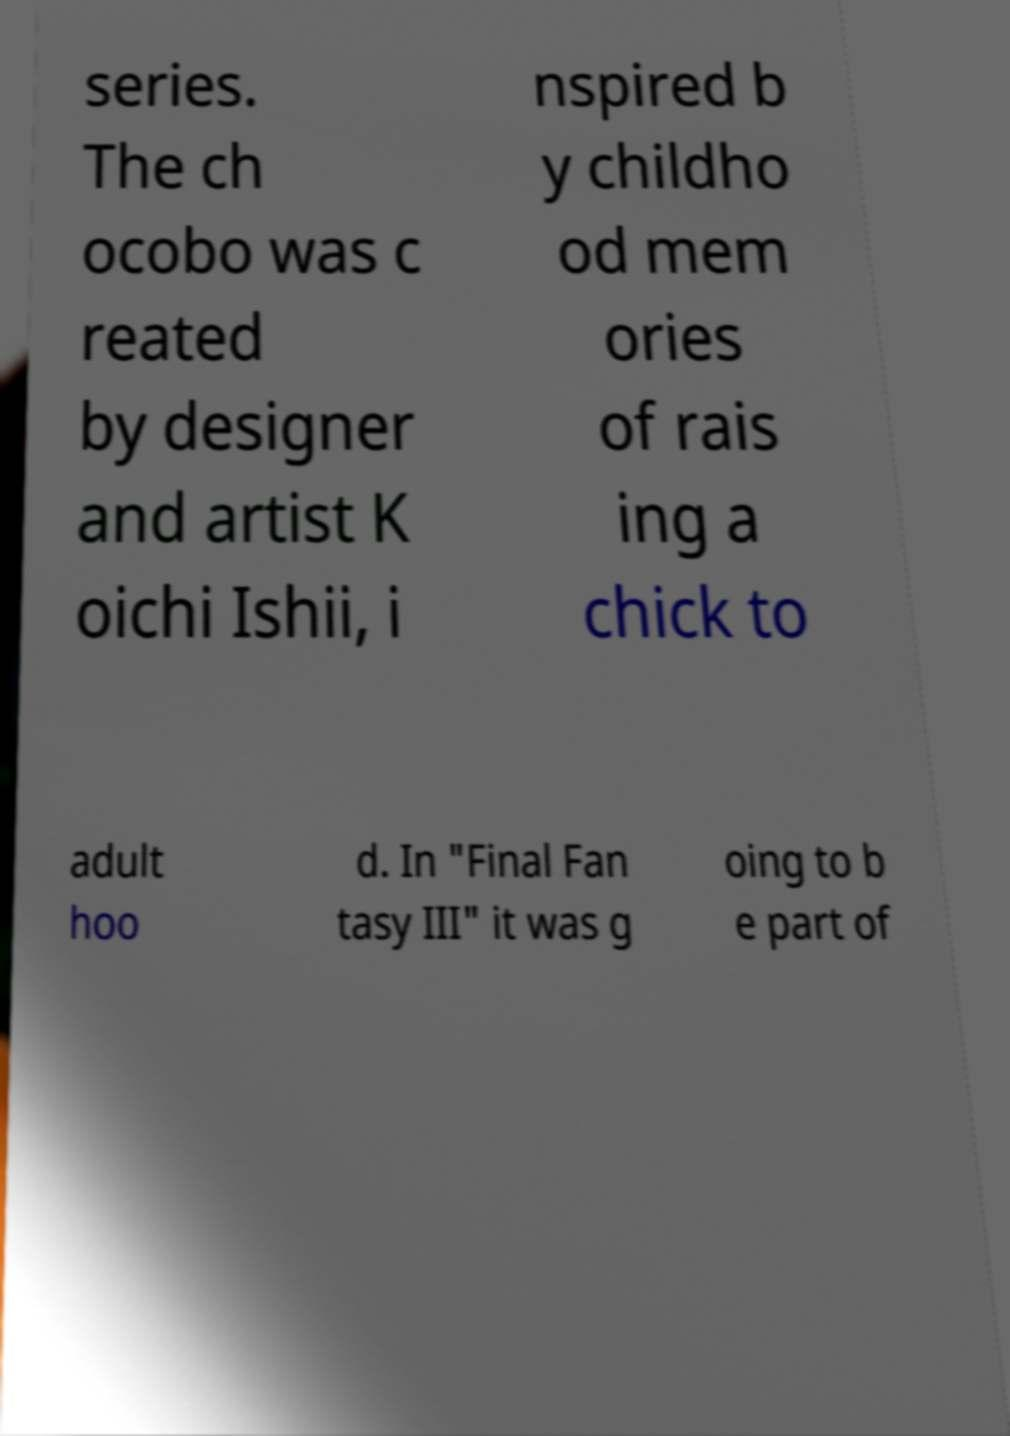There's text embedded in this image that I need extracted. Can you transcribe it verbatim? series. The ch ocobo was c reated by designer and artist K oichi Ishii, i nspired b y childho od mem ories of rais ing a chick to adult hoo d. In "Final Fan tasy III" it was g oing to b e part of 